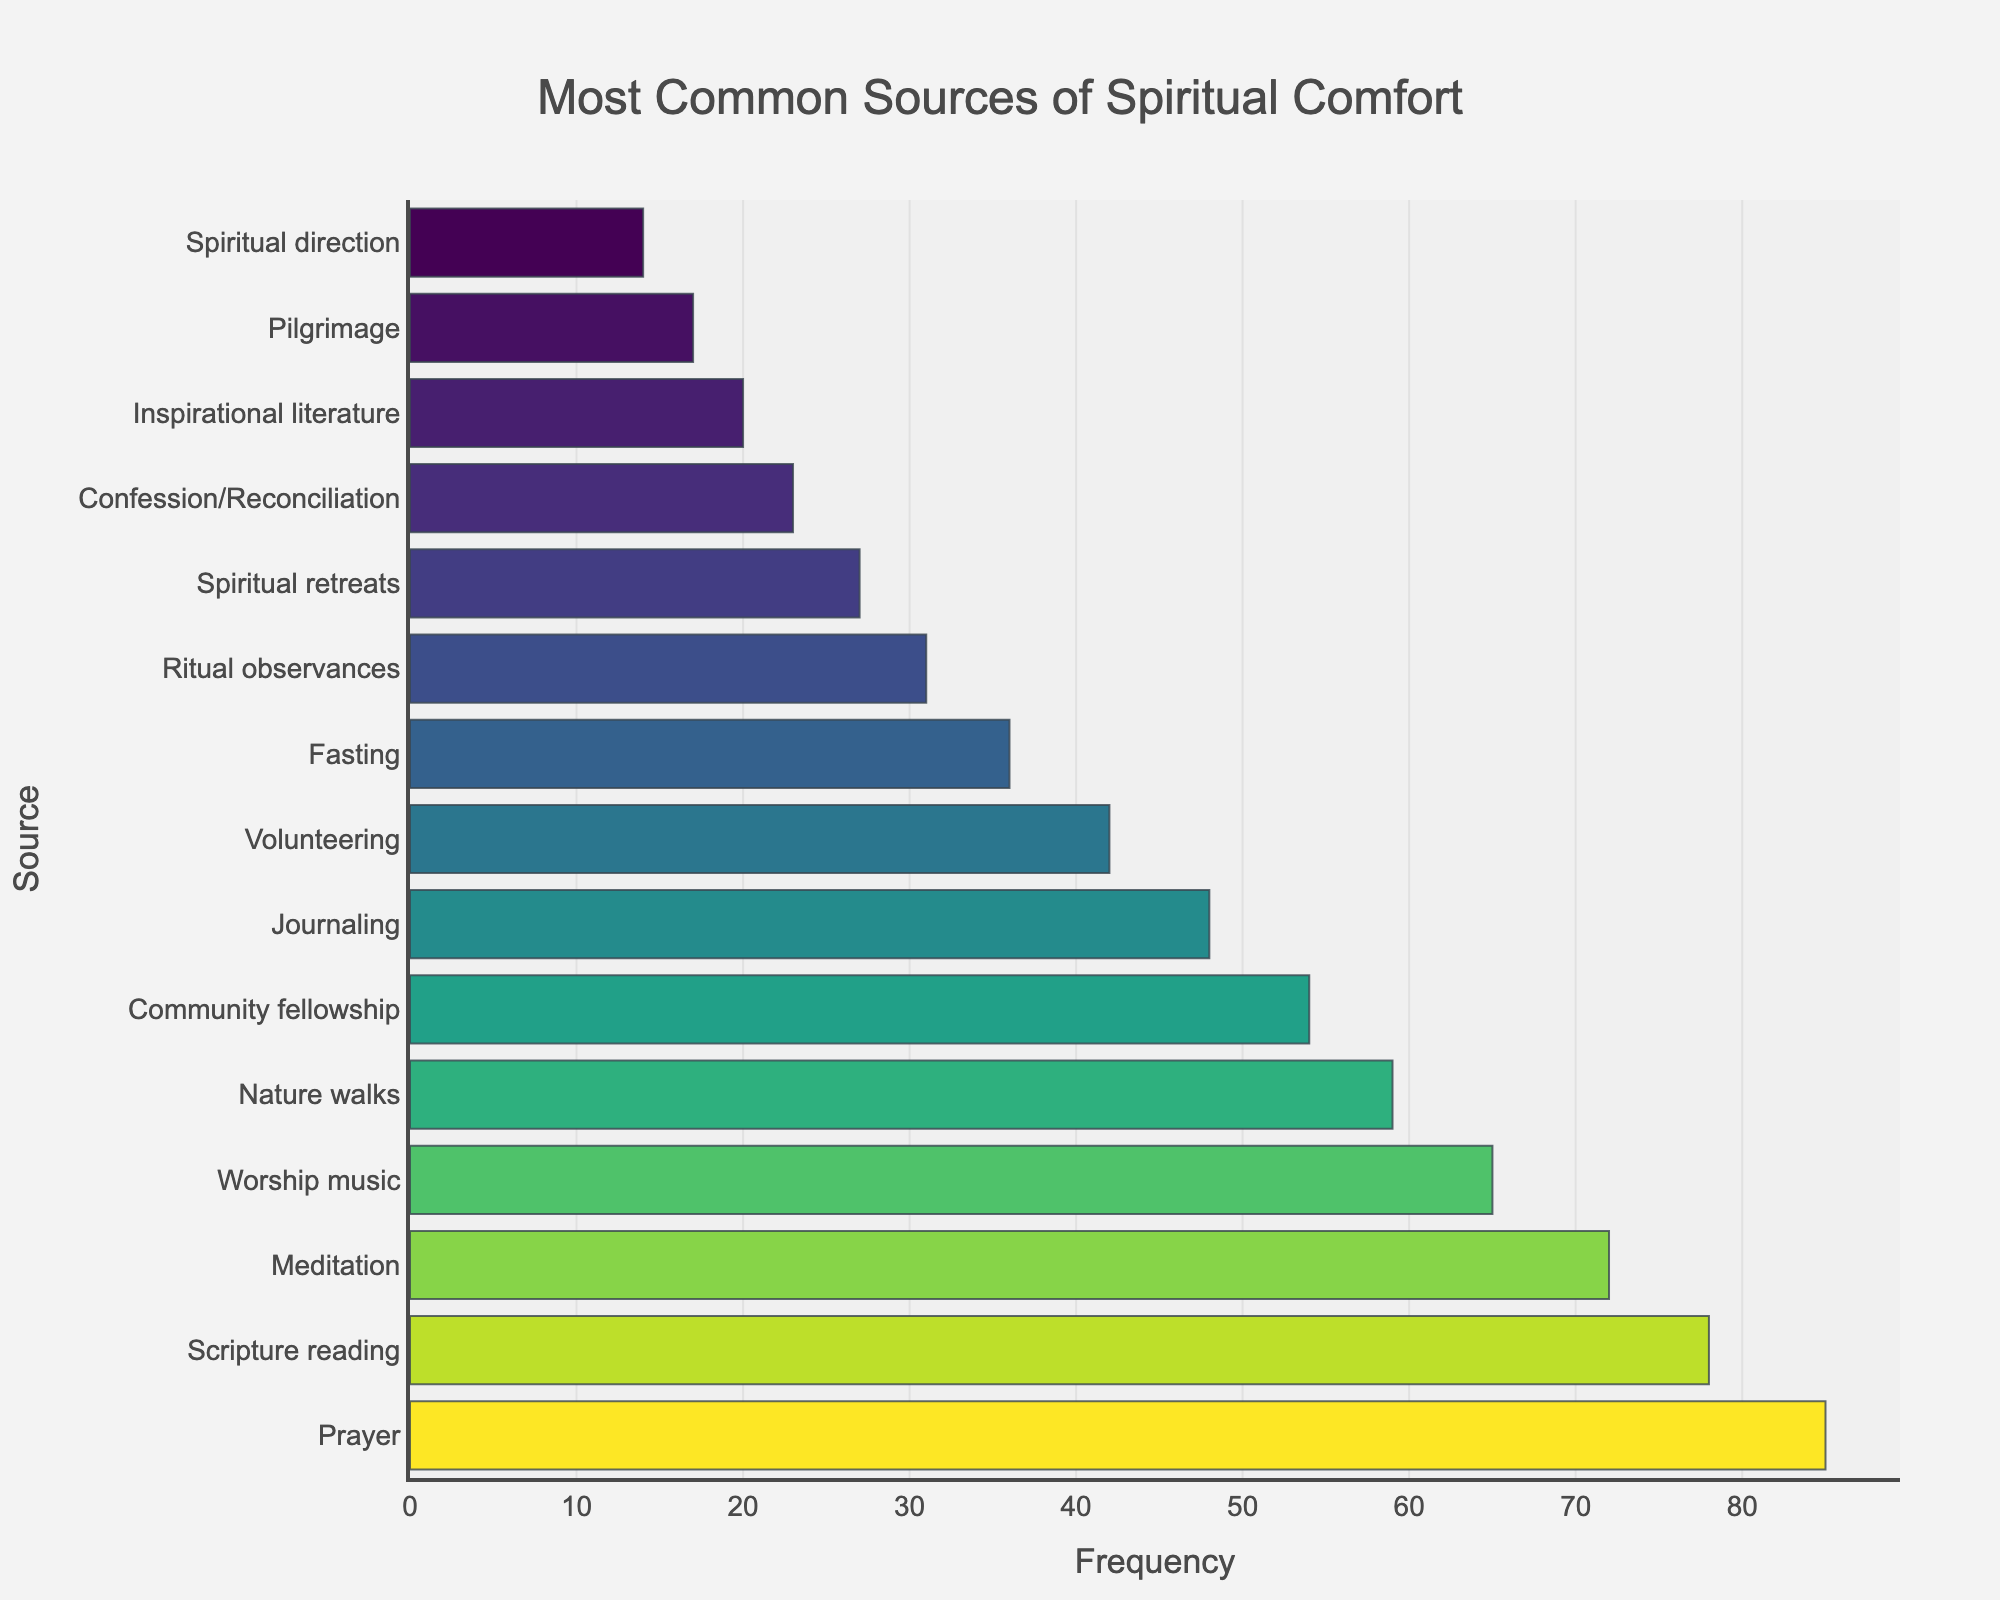What is the most common source of spiritual comfort? To find the most common source, look for the bar with the highest frequency.
Answer: Prayer Which source has a slightly lower frequency than 'Scripture reading'? Identify the frequency of 'Scripture reading', then find the source with the next lower frequency based on the height of the bars.
Answer: Meditation How many sources have a frequency greater than 50? Count the bars with heights corresponding to frequencies over 50.
Answer: 6 What is the sum of the frequencies of 'Journaling' and 'Volunteering'? Add the frequencies of 'Journaling' (48) and 'Volunteering' (42).
Answer: 90 Which sources have frequencies within 2 units of 36? Identify sources with frequencies between 34 and 38.
Answer: Fasting Is 'Nature walks' more common than 'Community fellowship'? Compare the frequencies of 'Nature walks' (59) and 'Community fellowship' (54).
Answer: Yes Which has a larger frequency: 'Ritual observances' or 'Confession/Reconciliation'? Compare the frequencies of 'Ritual observances' (31) and 'Confession/Reconciliation' (23).
Answer: Ritual observances What is the median frequency value of all sources? Order all the frequency values and find the middle value. For 15 values, the median is the 8th value.
Answer: 42 What is the difference in frequency between 'Worship music' and 'Inspirational literature'? Subtract the frequency of 'Inspirational literature' (20) from 'Worship music' (65).
Answer: 45 How does the bar color typically change as the frequency increases? Observe the color scale used in the chart, noting any changes in color as frequency values increase.
Answer: It changes to darker shades 